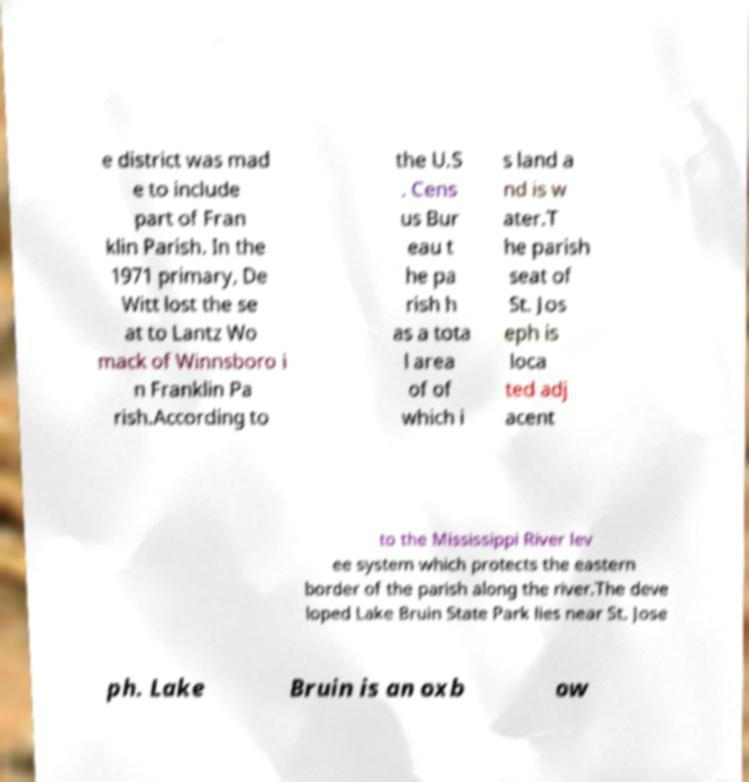There's text embedded in this image that I need extracted. Can you transcribe it verbatim? e district was mad e to include part of Fran klin Parish. In the 1971 primary, De Witt lost the se at to Lantz Wo mack of Winnsboro i n Franklin Pa rish.According to the U.S . Cens us Bur eau t he pa rish h as a tota l area of of which i s land a nd is w ater.T he parish seat of St. Jos eph is loca ted adj acent to the Mississippi River lev ee system which protects the eastern border of the parish along the river.The deve loped Lake Bruin State Park lies near St. Jose ph. Lake Bruin is an oxb ow 